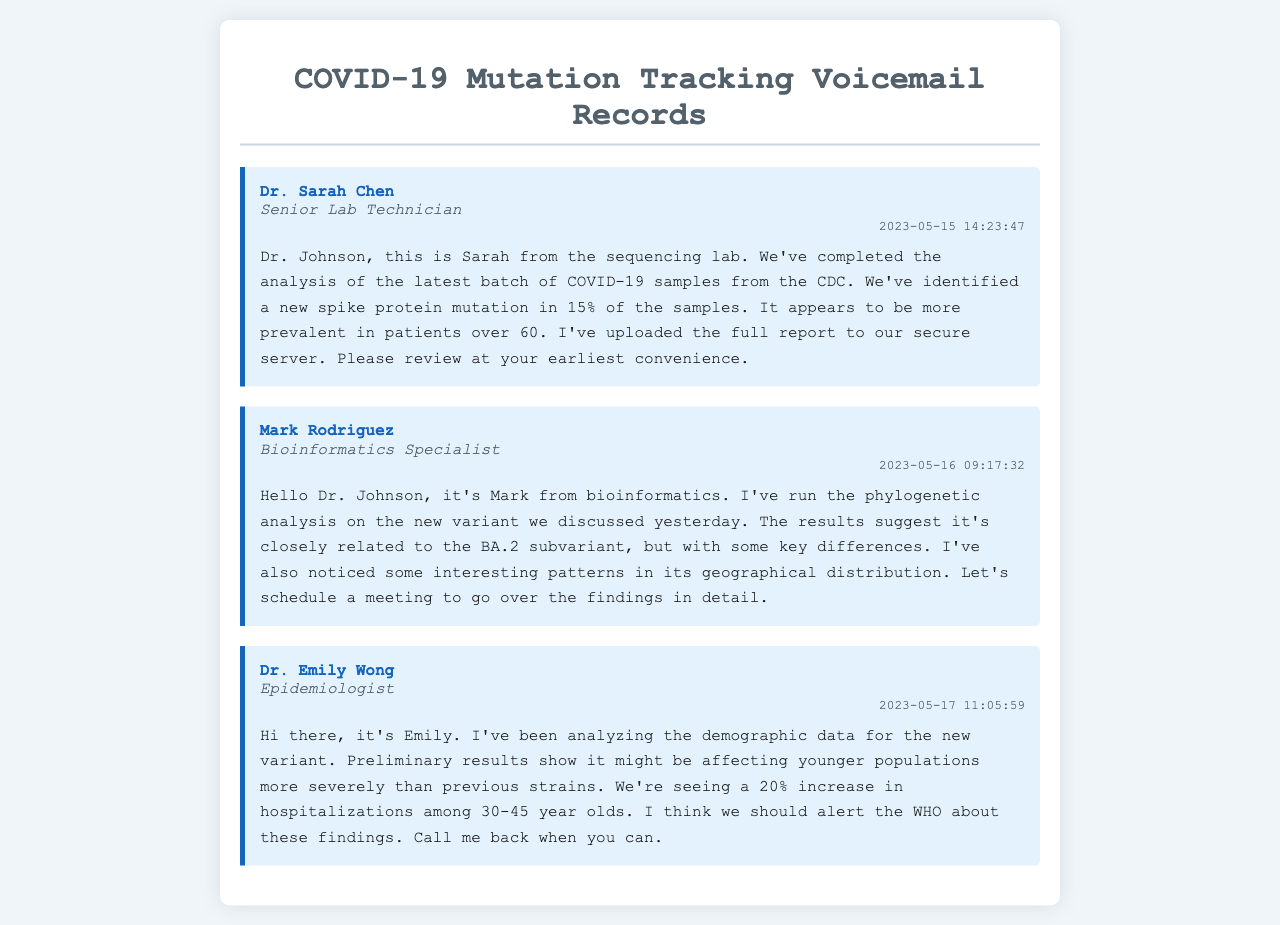What is the name of the first caller? The first caller mentioned in the voicemail is Dr. Sarah Chen.
Answer: Dr. Sarah Chen What percentage of samples showed the new spike protein mutation? Dr. Sarah Chen reported that 15% of the samples had a new spike protein mutation.
Answer: 15% Who conducted the phylogenetic analysis? The phylogenetic analysis was conducted by Mark Rodriguez.
Answer: Mark Rodriguez What demographic group is experiencing a higher hospitalization rate according to Dr. Emily Wong? Dr. Emily Wong indicated that the demographic group of 30-45 year olds is experiencing a higher hospitalization rate.
Answer: 30-45 year olds When was the voicemail from Dr. Sarah Chen left? Dr. Sarah Chen's voicemail was left on May 15, 2023.
Answer: May 15, 2023 What key differences were noted in the new variant's relation to BA.2? Mark Rodriguez noted that the new variant is closely related to the BA.2 subvariant but with some key differences.
Answer: Key differences How much has hospitalizations increased among younger populations? Dr. Emily Wong reported a 20% increase in hospitalizations among younger populations.
Answer: 20% What position does Mark Rodriguez hold? Mark Rodriguez is a Bioinformatics Specialist.
Answer: Bioinformatics Specialist Is there a report uploaded for review? Yes, Dr. Sarah Chen mentioned that she uploaded the full report to the secure server for review.
Answer: Yes 